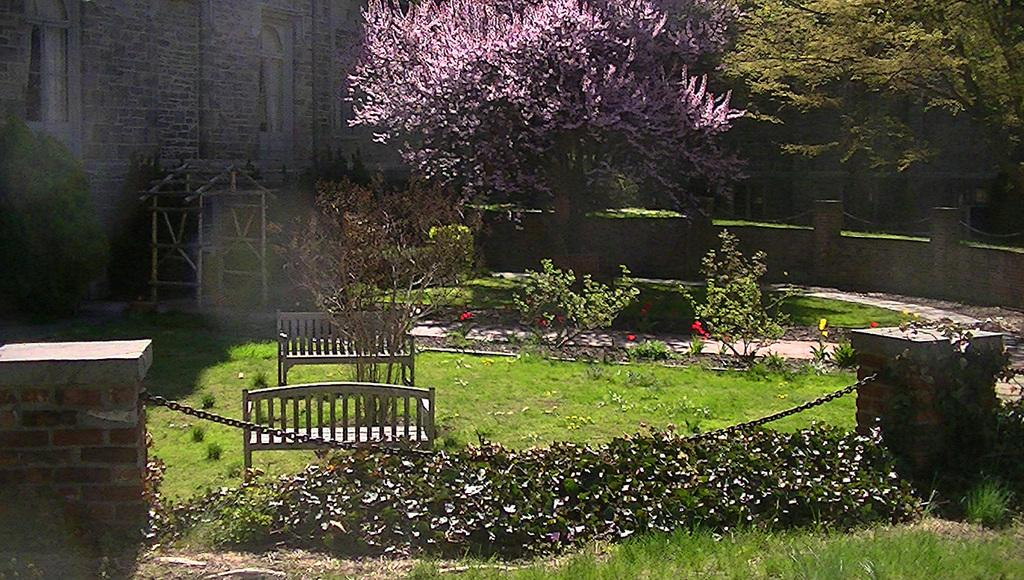What type of vegetation is present in the image? There is grass in the image. What type of seating is available in the image? There are benches in the image. What other types of vegetation can be seen in the image? There are plants and trees in the image. What type of man-made structures are visible in the image? There are buildings in the image. Can you see a fireman putting out a fire in the image? There is no fireman or fire present in the image. What type of animal can be seen grazing on the grass in the image? There is no animal, such as a goat, present in the image. 